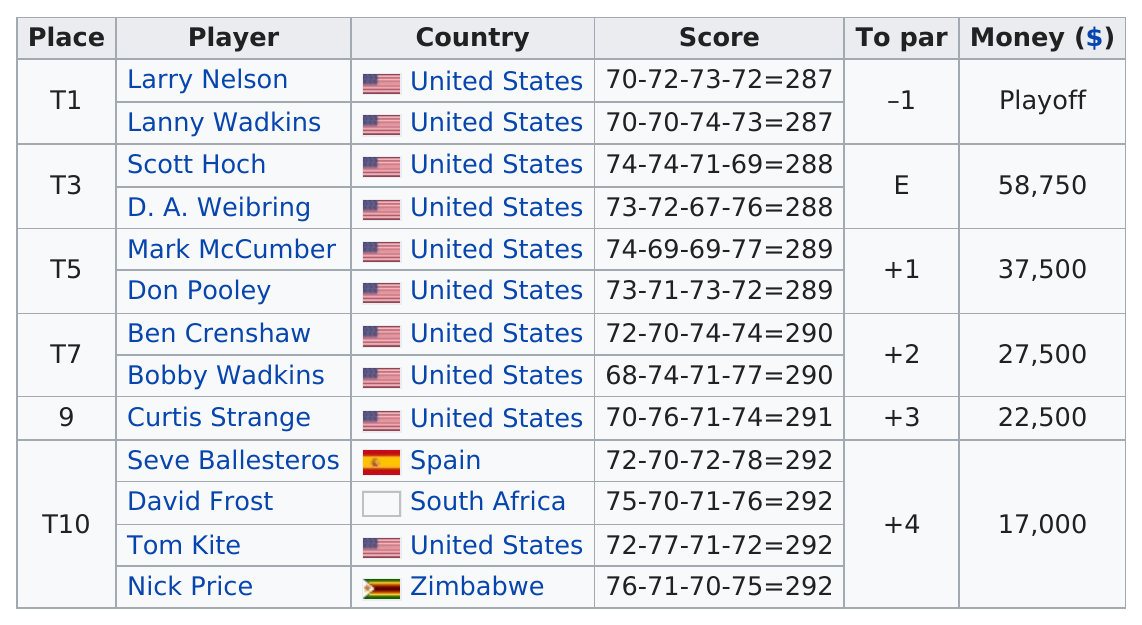Point out several critical features in this image. The subsequent player listed after Curtis Strange is Seve Ballesteros. What was the difference between the first place and par in the race? The United States is listed as the country 10 times in total. Bobby Wadkins had the same score as Ben Crenshaw, which is notable because both golfers achieved a similar performance. The first player listed on this chart is Larry Nelson. 